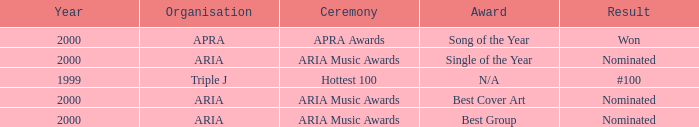What were the results before the year 2000? #100. 